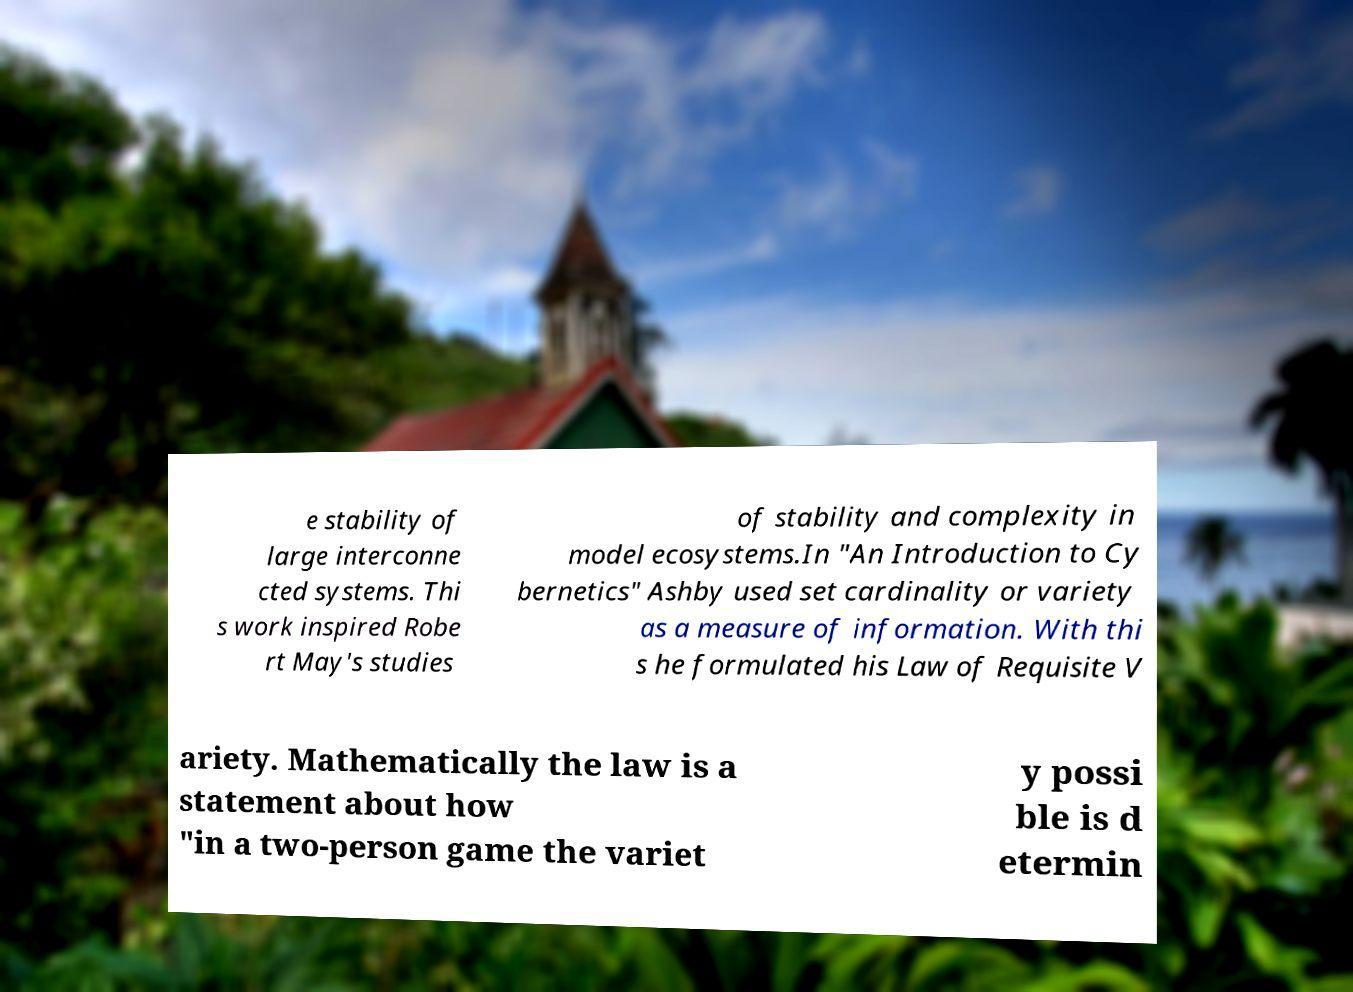There's text embedded in this image that I need extracted. Can you transcribe it verbatim? e stability of large interconne cted systems. Thi s work inspired Robe rt May's studies of stability and complexity in model ecosystems.In "An Introduction to Cy bernetics" Ashby used set cardinality or variety as a measure of information. With thi s he formulated his Law of Requisite V ariety. Mathematically the law is a statement about how "in a two-person game the variet y possi ble is d etermin 